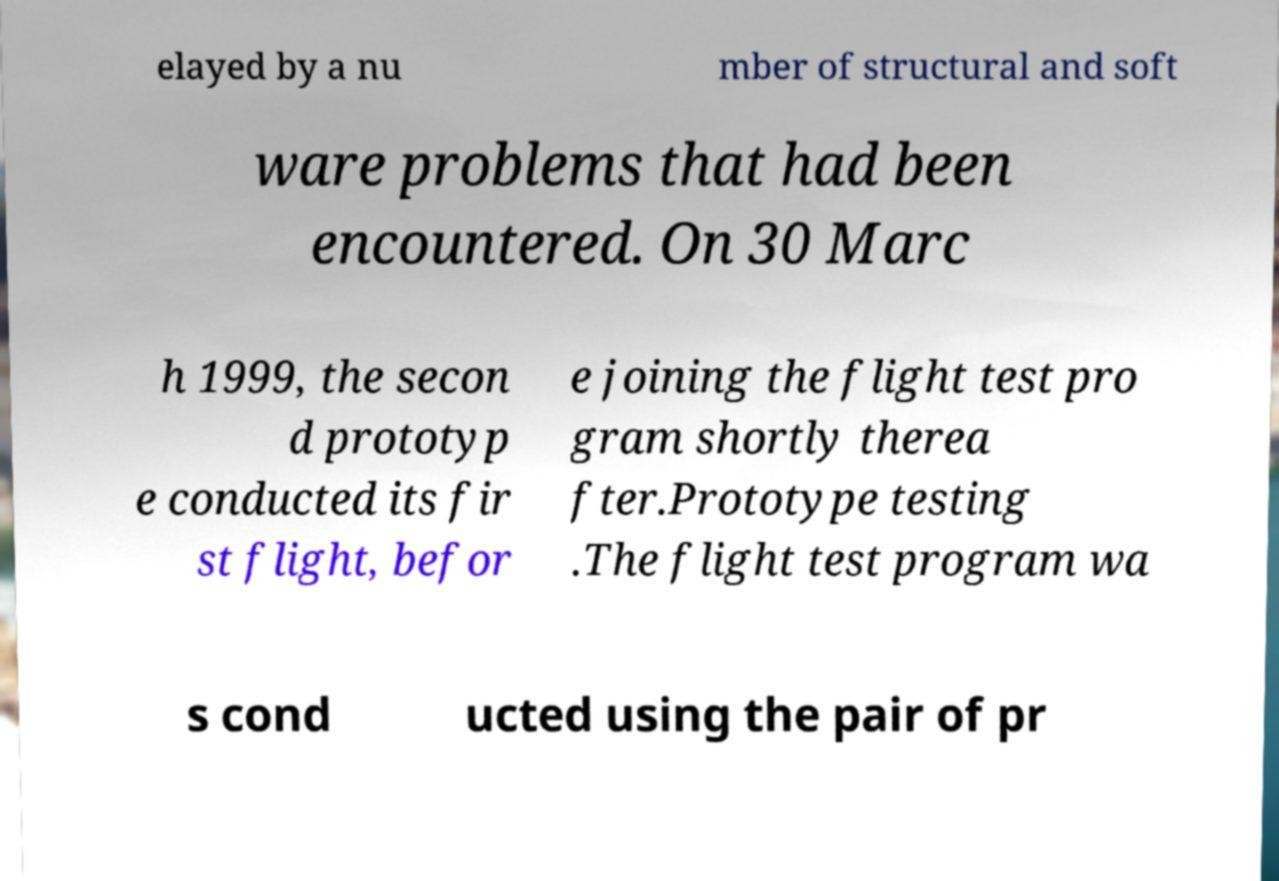For documentation purposes, I need the text within this image transcribed. Could you provide that? elayed by a nu mber of structural and soft ware problems that had been encountered. On 30 Marc h 1999, the secon d prototyp e conducted its fir st flight, befor e joining the flight test pro gram shortly therea fter.Prototype testing .The flight test program wa s cond ucted using the pair of pr 